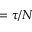<formula> <loc_0><loc_0><loc_500><loc_500>= \tau / N</formula> 